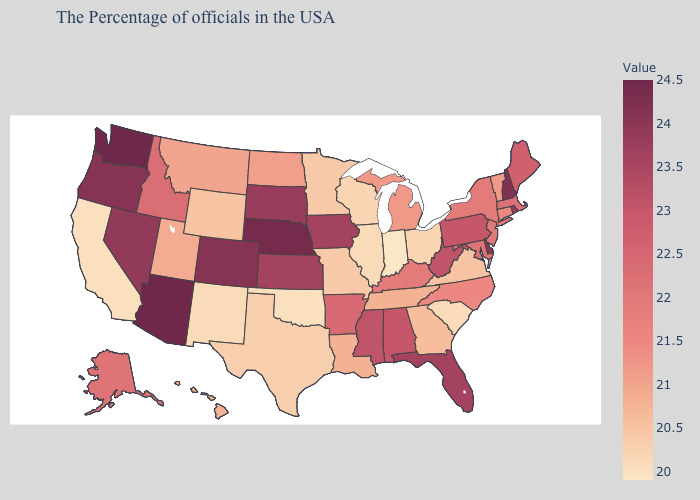Which states have the lowest value in the USA?
Concise answer only. Indiana. Among the states that border Ohio , does Michigan have the lowest value?
Quick response, please. No. Does Oklahoma have a lower value than Florida?
Answer briefly. Yes. Which states hav the highest value in the MidWest?
Answer briefly. Nebraska. Does Delaware have the highest value in the USA?
Quick response, please. No. Among the states that border Kansas , which have the lowest value?
Quick response, please. Oklahoma. Does the map have missing data?
Short answer required. No. 